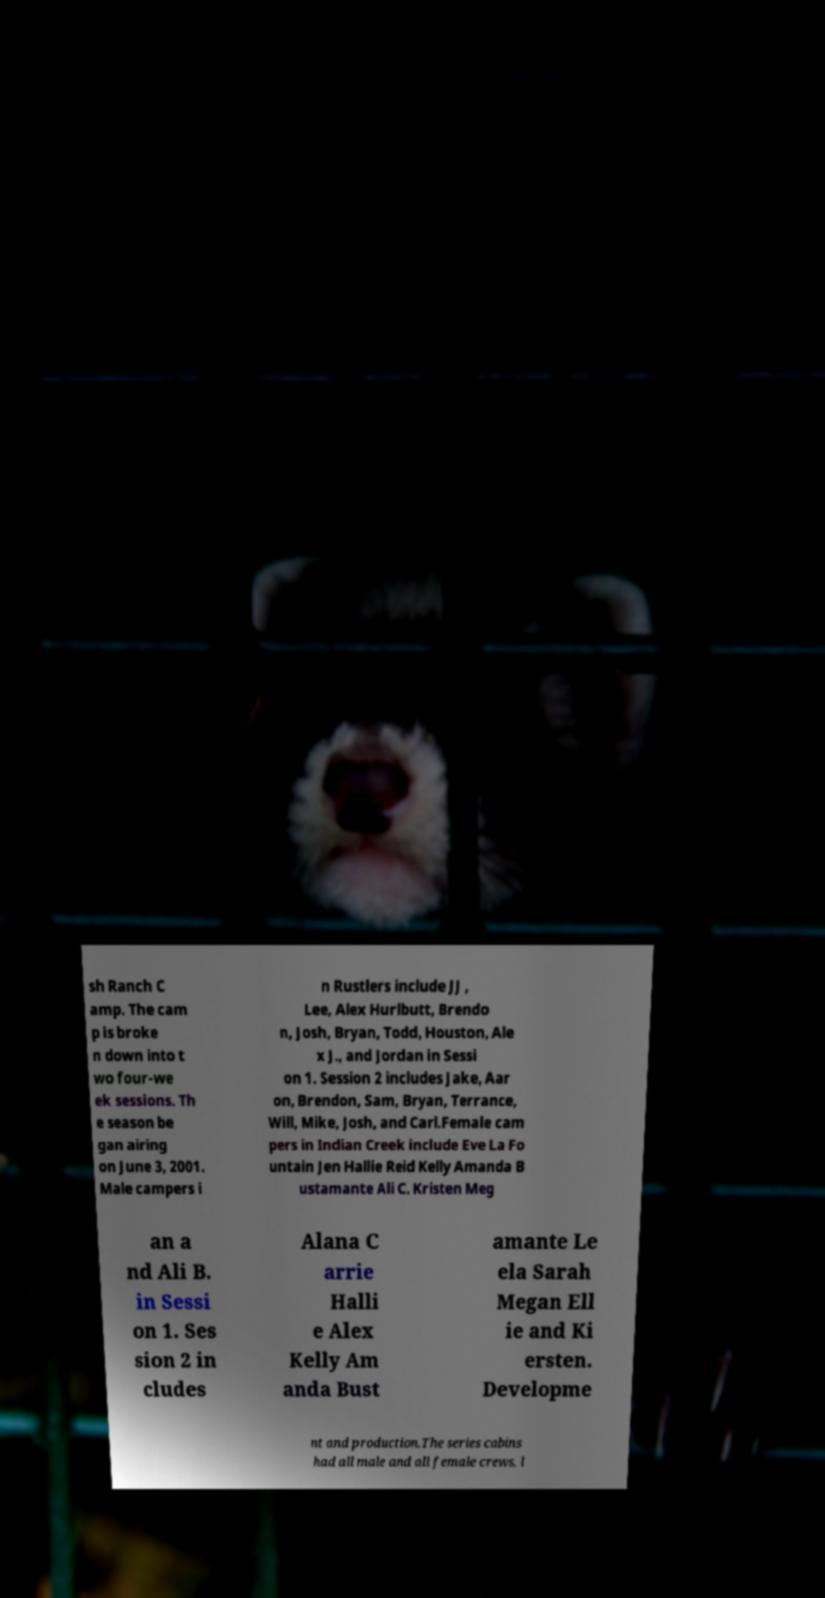Please read and relay the text visible in this image. What does it say? sh Ranch C amp. The cam p is broke n down into t wo four-we ek sessions. Th e season be gan airing on June 3, 2001. Male campers i n Rustlers include JJ , Lee, Alex Hurlbutt, Brendo n, Josh, Bryan, Todd, Houston, Ale x J., and Jordan in Sessi on 1. Session 2 includes Jake, Aar on, Brendon, Sam, Bryan, Terrance, Will, Mike, Josh, and Carl.Female cam pers in Indian Creek include Eve La Fo untain Jen Hallie Reid Kelly Amanda B ustamante Ali C. Kristen Meg an a nd Ali B. in Sessi on 1. Ses sion 2 in cludes Alana C arrie Halli e Alex Kelly Am anda Bust amante Le ela Sarah Megan Ell ie and Ki ersten. Developme nt and production.The series cabins had all male and all female crews, l 